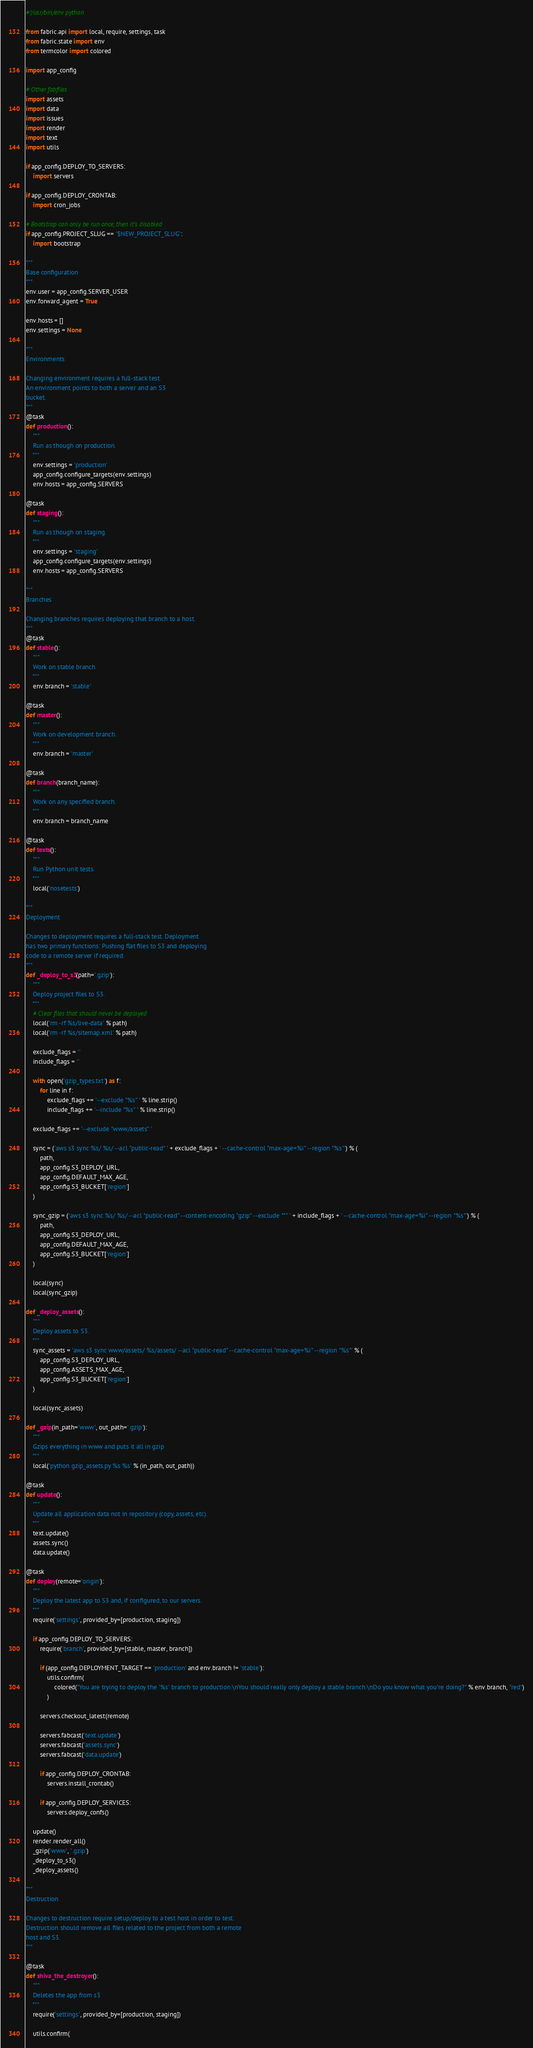<code> <loc_0><loc_0><loc_500><loc_500><_Python_>#!/usr/bin/env python

from fabric.api import local, require, settings, task
from fabric.state import env
from termcolor import colored

import app_config

# Other fabfiles
import assets
import data
import issues
import render
import text
import utils

if app_config.DEPLOY_TO_SERVERS:
    import servers

if app_config.DEPLOY_CRONTAB:
    import cron_jobs

# Bootstrap can only be run once, then it's disabled
if app_config.PROJECT_SLUG == '$NEW_PROJECT_SLUG':
    import bootstrap

"""
Base configuration
"""
env.user = app_config.SERVER_USER
env.forward_agent = True

env.hosts = []
env.settings = None

"""
Environments

Changing environment requires a full-stack test.
An environment points to both a server and an S3
bucket.
"""
@task
def production():
    """
    Run as though on production.
    """
    env.settings = 'production'
    app_config.configure_targets(env.settings)
    env.hosts = app_config.SERVERS

@task
def staging():
    """
    Run as though on staging.
    """
    env.settings = 'staging'
    app_config.configure_targets(env.settings)
    env.hosts = app_config.SERVERS

"""
Branches

Changing branches requires deploying that branch to a host.
"""
@task
def stable():
    """
    Work on stable branch.
    """
    env.branch = 'stable'

@task
def master():
    """
    Work on development branch.
    """
    env.branch = 'master'

@task
def branch(branch_name):
    """
    Work on any specified branch.
    """
    env.branch = branch_name

@task
def tests():
    """
    Run Python unit tests.
    """
    local('nosetests')

"""
Deployment

Changes to deployment requires a full-stack test. Deployment
has two primary functions: Pushing flat files to S3 and deploying
code to a remote server if required.
"""
def _deploy_to_s3(path='.gzip'):
    """
    Deploy project files to S3.
    """
    # Clear files that should never be deployed
    local('rm -rf %s/live-data' % path)
    local('rm -rf %s/sitemap.xml' % path)

    exclude_flags = ''
    include_flags = ''

    with open('gzip_types.txt') as f:
        for line in f:
            exclude_flags += '--exclude "%s" ' % line.strip()
            include_flags += '--include "%s" ' % line.strip()

    exclude_flags += '--exclude "www/assets" '
    
    sync = ('aws s3 sync %s/ %s/ --acl "public-read" ' + exclude_flags + ' --cache-control "max-age=%i" --region "%s"') % (
        path,
        app_config.S3_DEPLOY_URL,
        app_config.DEFAULT_MAX_AGE,
        app_config.S3_BUCKET['region']
    )

    sync_gzip = ('aws s3 sync %s/ %s/ --acl "public-read" --content-encoding "gzip" --exclude "*" ' + include_flags + ' --cache-control "max-age=%i" --region "%s"') % (
        path,
        app_config.S3_DEPLOY_URL,
        app_config.DEFAULT_MAX_AGE,
        app_config.S3_BUCKET['region']
    )

    local(sync)
    local(sync_gzip)

def _deploy_assets():
    """
    Deploy assets to S3.
    """
    sync_assets = 'aws s3 sync www/assets/ %s/assets/ --acl "public-read" --cache-control "max-age=%i" --region "%s"' % (
        app_config.S3_DEPLOY_URL,
        app_config.ASSETS_MAX_AGE,
        app_config.S3_BUCKET['region']
    )

    local(sync_assets)

def _gzip(in_path='www', out_path='.gzip'):
    """
    Gzips everything in www and puts it all in gzip
    """
    local('python gzip_assets.py %s %s' % (in_path, out_path))

@task
def update():
    """
    Update all application data not in repository (copy, assets, etc).
    """
    text.update()
    assets.sync()
    data.update()

@task
def deploy(remote='origin'):
    """
    Deploy the latest app to S3 and, if configured, to our servers.
    """
    require('settings', provided_by=[production, staging])

    if app_config.DEPLOY_TO_SERVERS:
        require('branch', provided_by=[stable, master, branch])

        if (app_config.DEPLOYMENT_TARGET == 'production' and env.branch != 'stable'):
            utils.confirm(
                colored("You are trying to deploy the '%s' branch to production.\nYou should really only deploy a stable branch.\nDo you know what you're doing?" % env.branch, "red")
            )

        servers.checkout_latest(remote)

        servers.fabcast('text.update')
        servers.fabcast('assets.sync')
        servers.fabcast('data.update')

        if app_config.DEPLOY_CRONTAB:
            servers.install_crontab()

        if app_config.DEPLOY_SERVICES:
            servers.deploy_confs()

    update()
    render.render_all()
    _gzip('www', '.gzip')
    _deploy_to_s3()
    _deploy_assets()

"""
Destruction

Changes to destruction require setup/deploy to a test host in order to test.
Destruction should remove all files related to the project from both a remote
host and S3.
"""

@task
def shiva_the_destroyer():
    """
    Deletes the app from s3
    """
    require('settings', provided_by=[production, staging])

    utils.confirm(</code> 